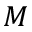<formula> <loc_0><loc_0><loc_500><loc_500>M</formula> 